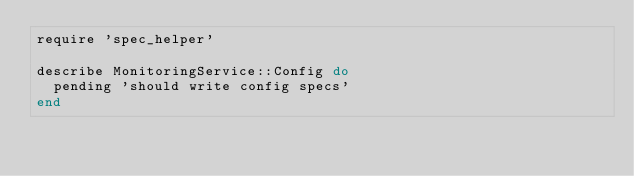<code> <loc_0><loc_0><loc_500><loc_500><_Ruby_>require 'spec_helper'

describe MonitoringService::Config do
  pending 'should write config specs'
end
</code> 